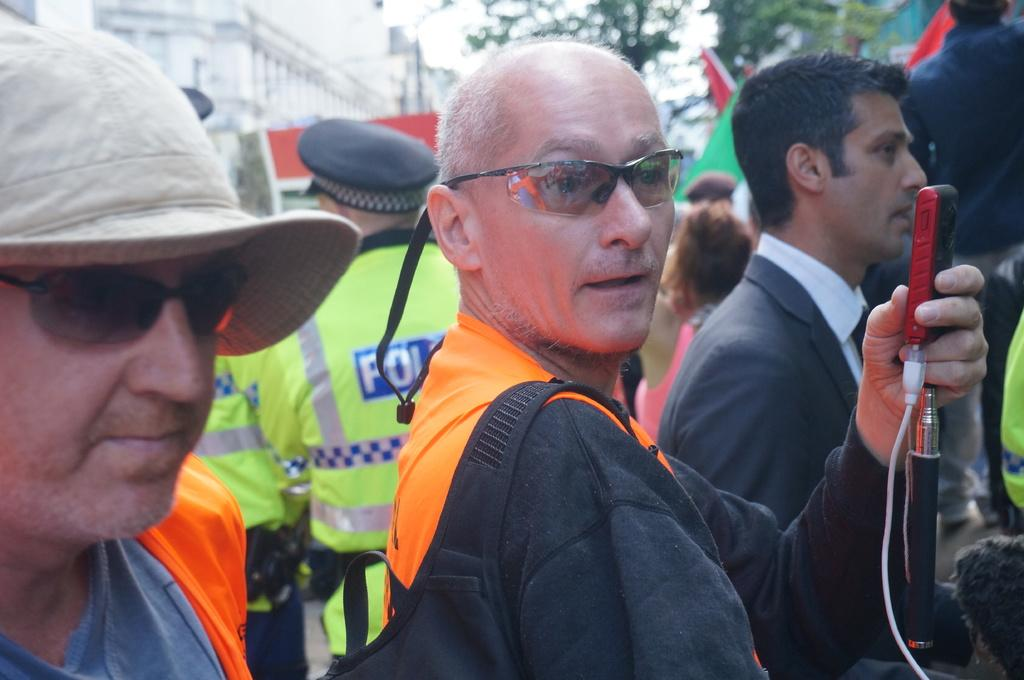What is the general setting of the image? There are many people standing in the foreground of the image. Can you describe a specific person in the image? There is a person on the left side wearing a cap. What type of person can be seen in the background of the image? There is a policeman visible in the background of the image. What type of food is being served at the vacation in the image? There is no mention of a vacation or food in the image; it simply shows a gathering of people with a policeman in the background. Can you describe the nail polish color of the person on the right side of the image? There is no information about nail polish or a person on the right side of the image; only a person wearing a cap on the left side is mentioned. 